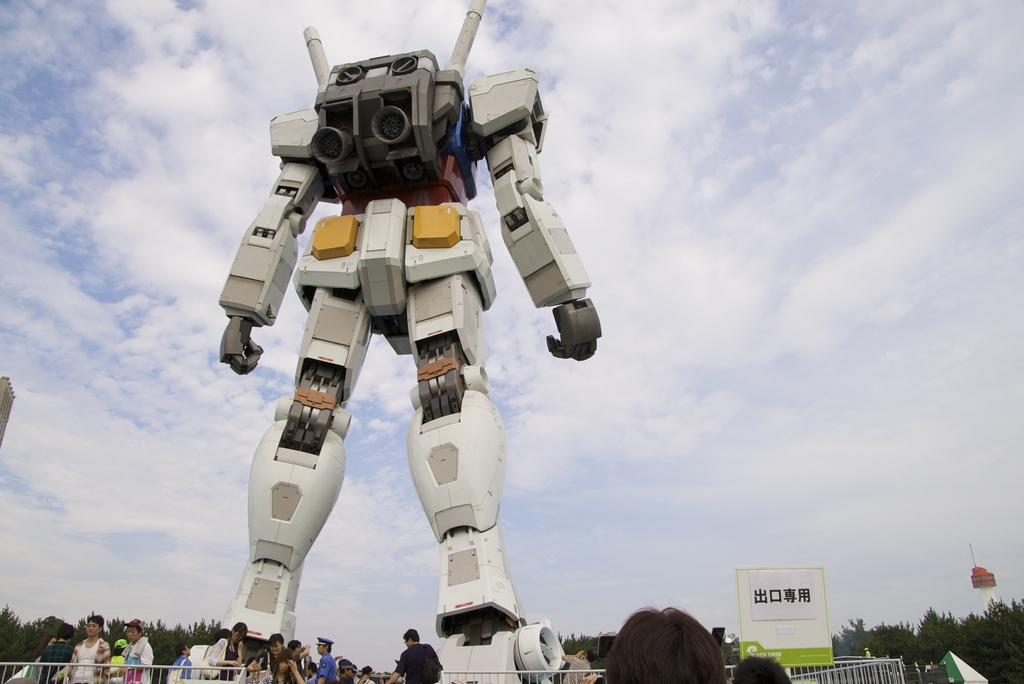What is the main subject of the image? There is a robot in the image. What can be seen in the background of the image? There is a fence in the image. Where are the people located in the image? The people are on the left side of the image. What is the red object in the air? There is a red object in the air, but it is not clear what it is from the image. What is the condition of the sky in the image? The sky is cloudy in the image. What type of achiever is the robot in the image? The image does not provide any information about the robot's achievements or capabilities, so it is not possible to determine if it is an achiever. Can you see any bees in the image? A: There are no bees visible in the image. 